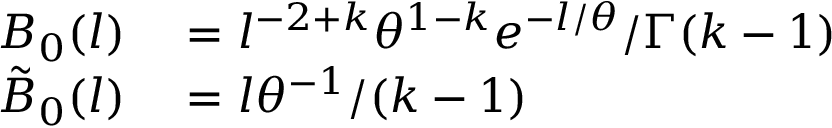Convert formula to latex. <formula><loc_0><loc_0><loc_500><loc_500>\begin{array} { r l } { B _ { 0 } ( l ) } & = l ^ { - 2 + k } \theta ^ { 1 - k } e ^ { - l / \theta } / \Gamma ( k - 1 ) } \\ { \tilde { B } _ { 0 } ( l ) } & = l \theta ^ { - 1 } / ( k - 1 ) } \end{array}</formula> 